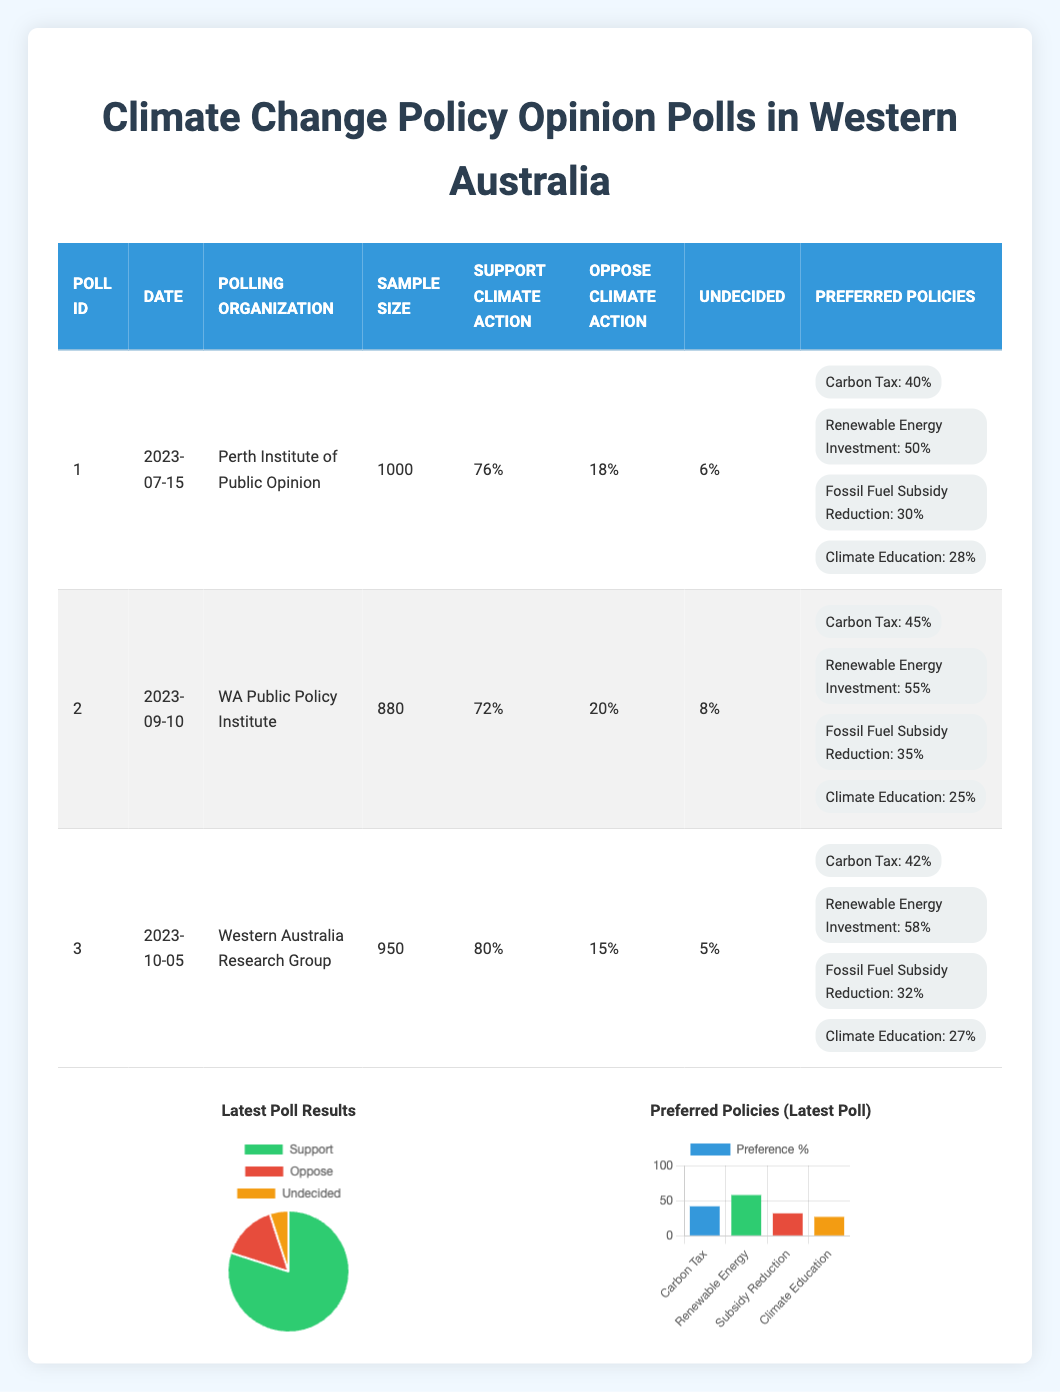What percentage of respondents supported climate action in the latest poll? The latest poll is PollID 3, which was conducted on 2023-10-05. Referring to the "Support Climate Action" column, the percentage is 80%.
Answer: 80% How many respondents were undecided in the second poll? The second poll, PollID 2, conducted on 2023-09-10, shows in the "Undecided" column that 8% of respondents were undecided. The sample size was 880, so 8% of that is 70.4, but we are only reporting the percentage here.
Answer: 8% What is the difference in support for climate action between the first and third polls? The support for climate action in the first poll (PollID 1) is 76%, while in the third poll (PollID 3) it is 80%. The difference is 80% - 76% = 4%.
Answer: 4% Is there a higher preference for Renewable Energy Investment or Fossil Fuel Subsidy Reduction in the second poll? In PollID 2, the preference for Renewable Energy Investment is 55% and for Fossil Fuel Subsidy Reduction is 35%. Since 55% is greater than 35%, the answer is yes.
Answer: Yes What is the average percentage of support for climate action across all three polls? Adding the support percentages from all three polls gives us 76% + 72% + 80% = 228%. We divide this sum by the number of polls (3) to find the average: 228% / 3 = 76%.
Answer: 76% 